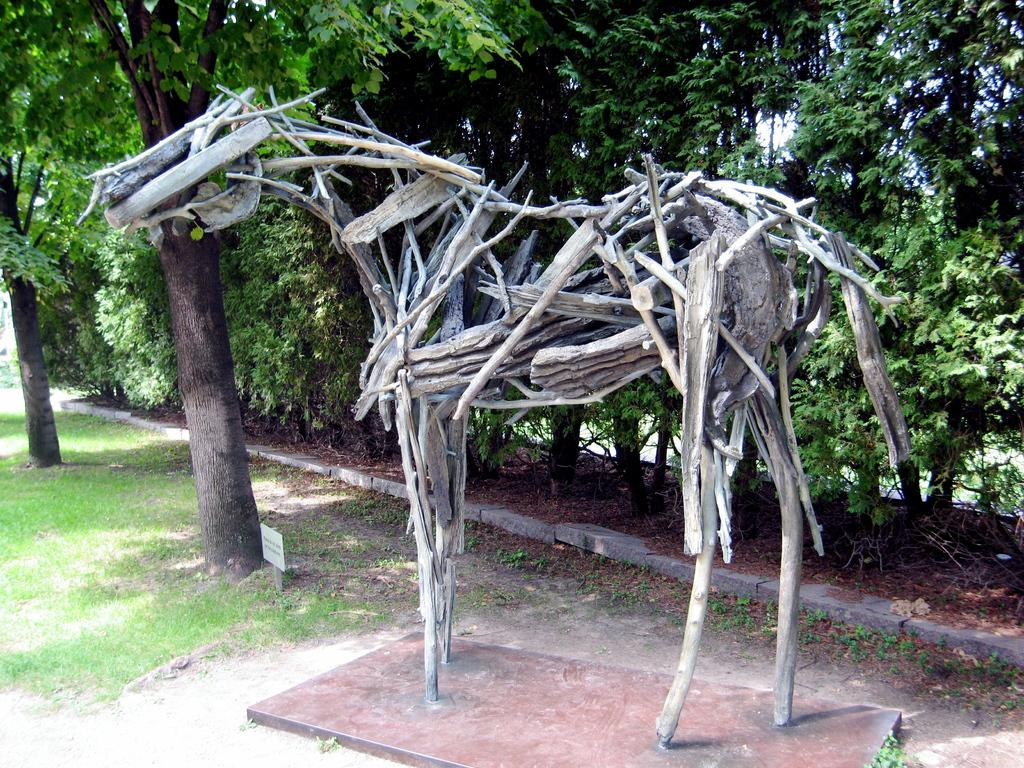What is the main subject of the image? There is an animal structure made up of wooden sticks in the image. What can be seen in the background of the image? There are many trees and a board visible in the background of the image. What color is the dirt surrounding the animal structure in the image? There is no dirt surrounding the animal structure in the image, as it is made up of wooden sticks. 